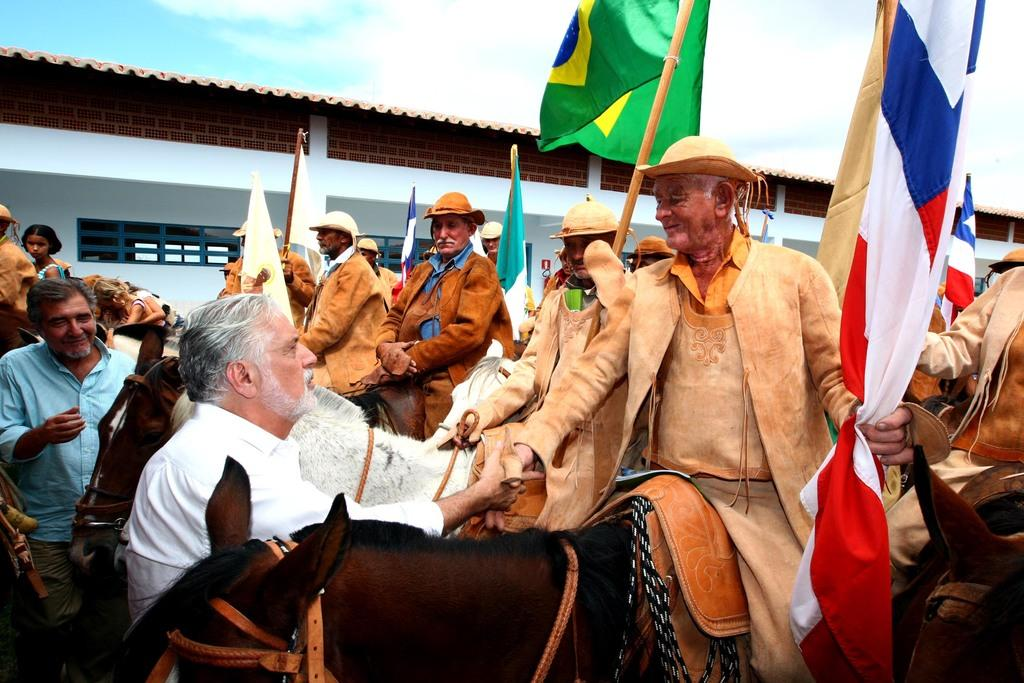How many people are in the image? There is a group of people in the image. What are the people doing in the image? Some people are standing, while others are seated on a horse. What are the people holding in their hands? The people are holding flags in their hands. What can be seen in the background of the image? There is a building in the background of the image. How many bears are visible in the image? There are no bears present in the image. What type of hospital can be seen in the background of the image? There is no hospital visible in the image; it features a building in the background. 